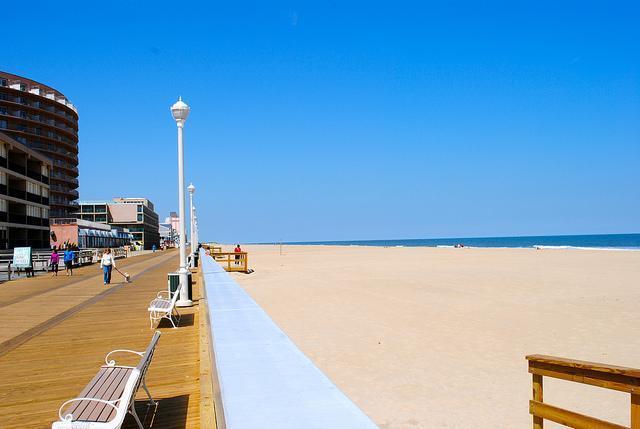How many benches are there?
Give a very brief answer. 2. How many pizza slices are missing from the tray?
Give a very brief answer. 0. 